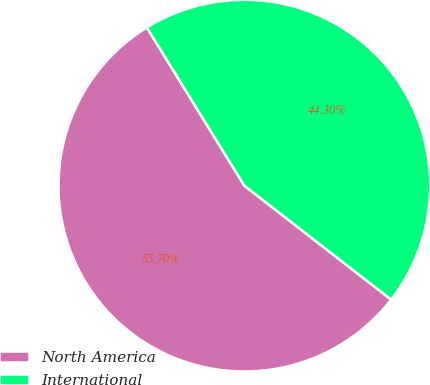<chart> <loc_0><loc_0><loc_500><loc_500><pie_chart><fcel>North America<fcel>International<nl><fcel>55.7%<fcel>44.3%<nl></chart> 